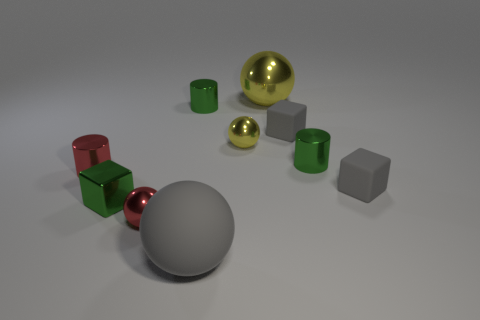Subtract 1 spheres. How many spheres are left? 3 Subtract all small rubber blocks. How many blocks are left? 1 Subtract all purple spheres. Subtract all purple blocks. How many spheres are left? 4 Subtract all balls. How many objects are left? 6 Subtract 1 green cubes. How many objects are left? 9 Subtract all rubber things. Subtract all large gray balls. How many objects are left? 6 Add 2 small green blocks. How many small green blocks are left? 3 Add 4 yellow objects. How many yellow objects exist? 6 